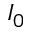Convert formula to latex. <formula><loc_0><loc_0><loc_500><loc_500>I _ { 0 }</formula> 